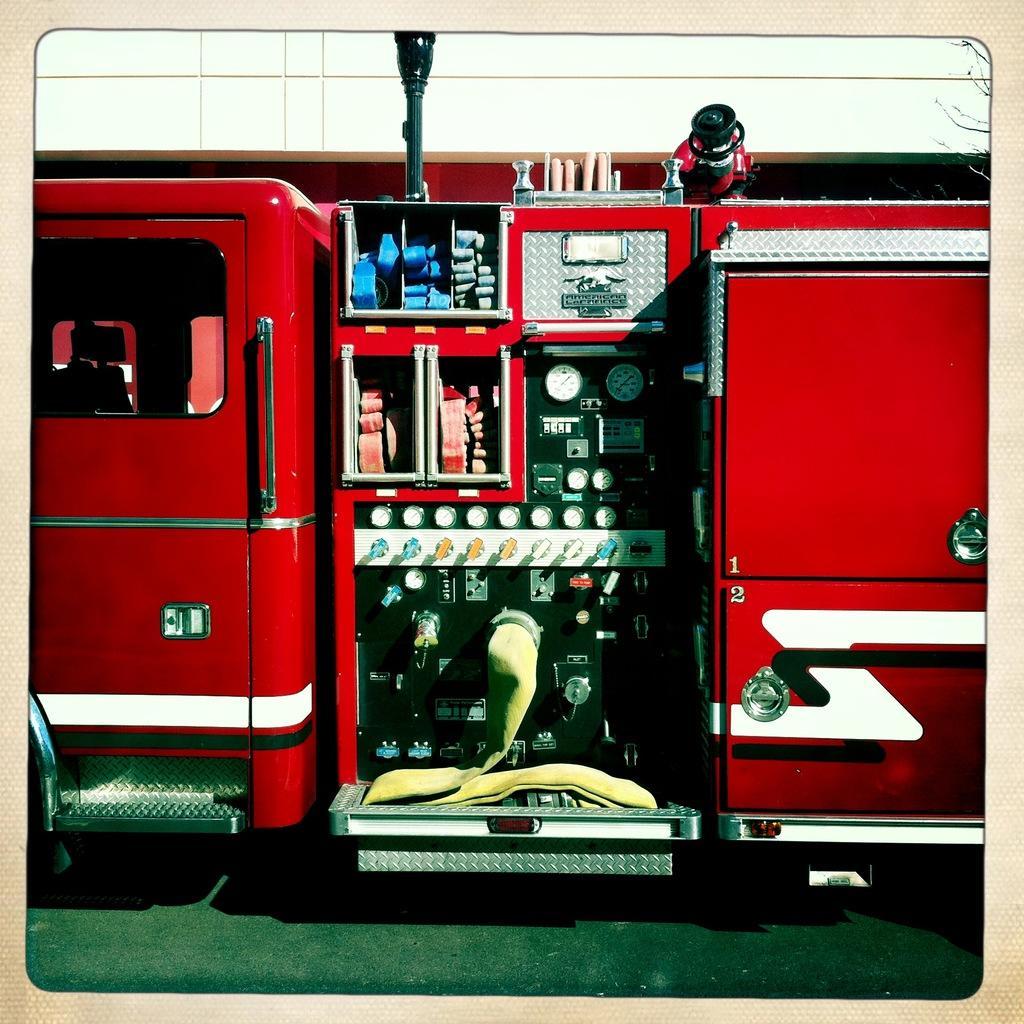How would you summarize this image in a sentence or two? In this image we can see a fire engine. There are meters and there is a pipe. Also we can see door and window. 